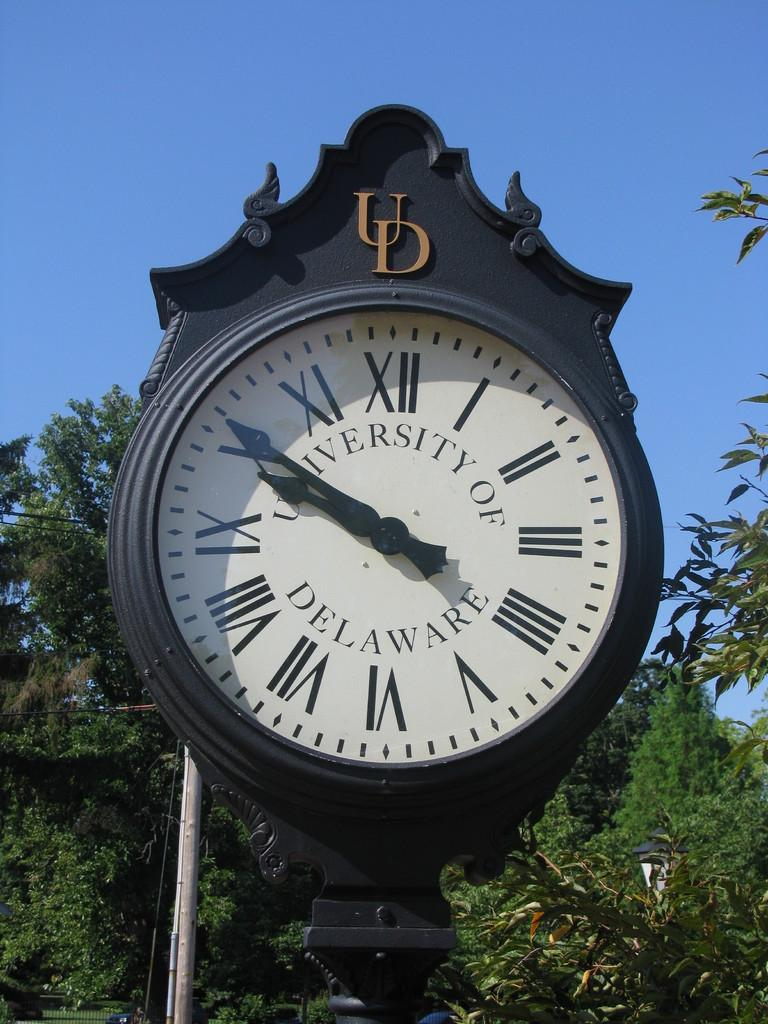<image>
Provide a brief description of the given image. University of Delawate black and white clock with roman numerals 